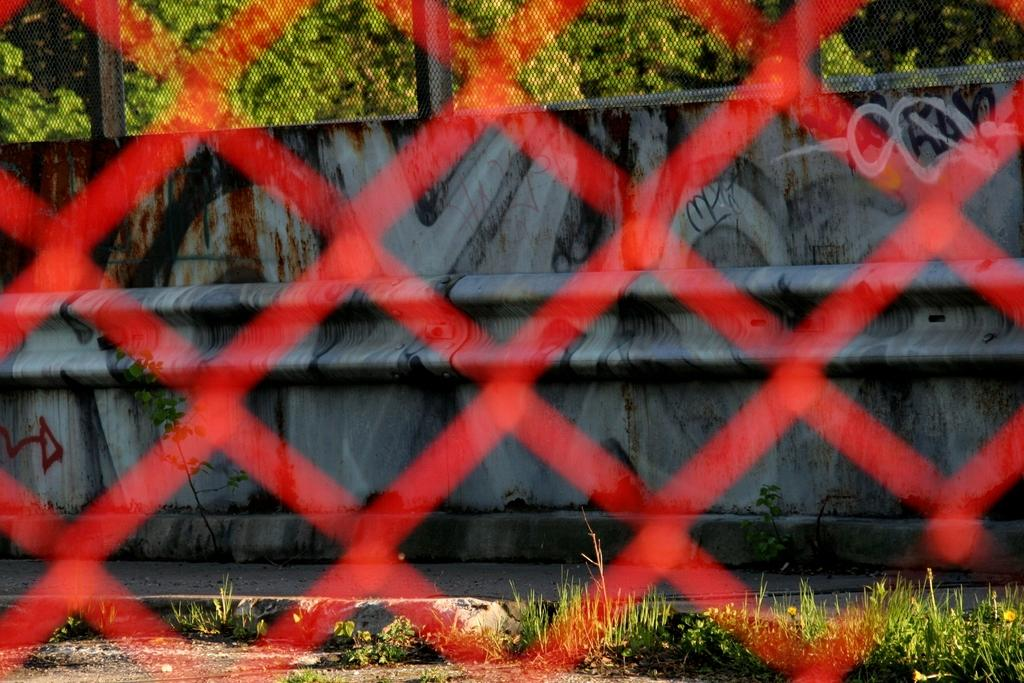What is located in the foreground of the image? There is a net in the foreground of the image. How is the net depicted in the image? The net is blurred in the image. What types of vegetation can be seen in the background of the image? There are plants, shrubs, trees, and a wall in the background of the image. What type of steel is visible in the image? There is no steel present in the image. How does the respect for the plants in the image manifest itself? The image does not depict any actions or emotions related to respect for the plants; it simply shows their presence in the background. 